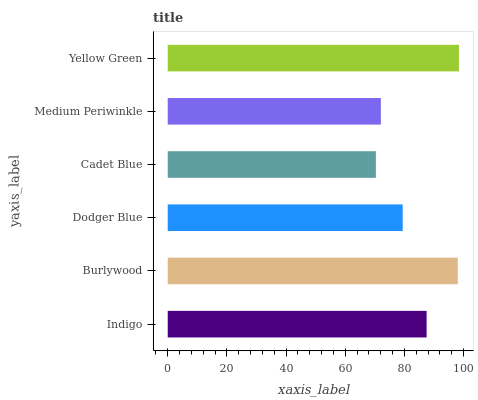Is Cadet Blue the minimum?
Answer yes or no. Yes. Is Yellow Green the maximum?
Answer yes or no. Yes. Is Burlywood the minimum?
Answer yes or no. No. Is Burlywood the maximum?
Answer yes or no. No. Is Burlywood greater than Indigo?
Answer yes or no. Yes. Is Indigo less than Burlywood?
Answer yes or no. Yes. Is Indigo greater than Burlywood?
Answer yes or no. No. Is Burlywood less than Indigo?
Answer yes or no. No. Is Indigo the high median?
Answer yes or no. Yes. Is Dodger Blue the low median?
Answer yes or no. Yes. Is Medium Periwinkle the high median?
Answer yes or no. No. Is Yellow Green the low median?
Answer yes or no. No. 